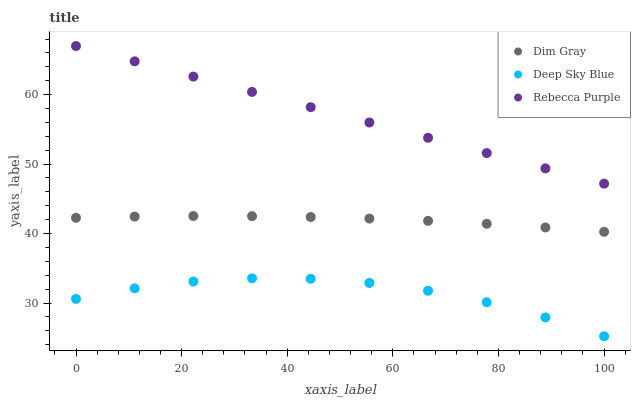Does Deep Sky Blue have the minimum area under the curve?
Answer yes or no. Yes. Does Rebecca Purple have the maximum area under the curve?
Answer yes or no. Yes. Does Rebecca Purple have the minimum area under the curve?
Answer yes or no. No. Does Deep Sky Blue have the maximum area under the curve?
Answer yes or no. No. Is Rebecca Purple the smoothest?
Answer yes or no. Yes. Is Deep Sky Blue the roughest?
Answer yes or no. Yes. Is Deep Sky Blue the smoothest?
Answer yes or no. No. Is Rebecca Purple the roughest?
Answer yes or no. No. Does Deep Sky Blue have the lowest value?
Answer yes or no. Yes. Does Rebecca Purple have the lowest value?
Answer yes or no. No. Does Rebecca Purple have the highest value?
Answer yes or no. Yes. Does Deep Sky Blue have the highest value?
Answer yes or no. No. Is Deep Sky Blue less than Rebecca Purple?
Answer yes or no. Yes. Is Rebecca Purple greater than Deep Sky Blue?
Answer yes or no. Yes. Does Deep Sky Blue intersect Rebecca Purple?
Answer yes or no. No. 